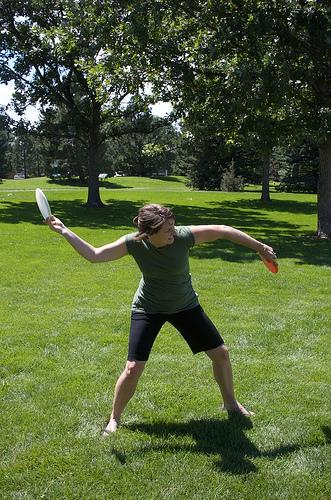What is this woman trying to hit? ball 